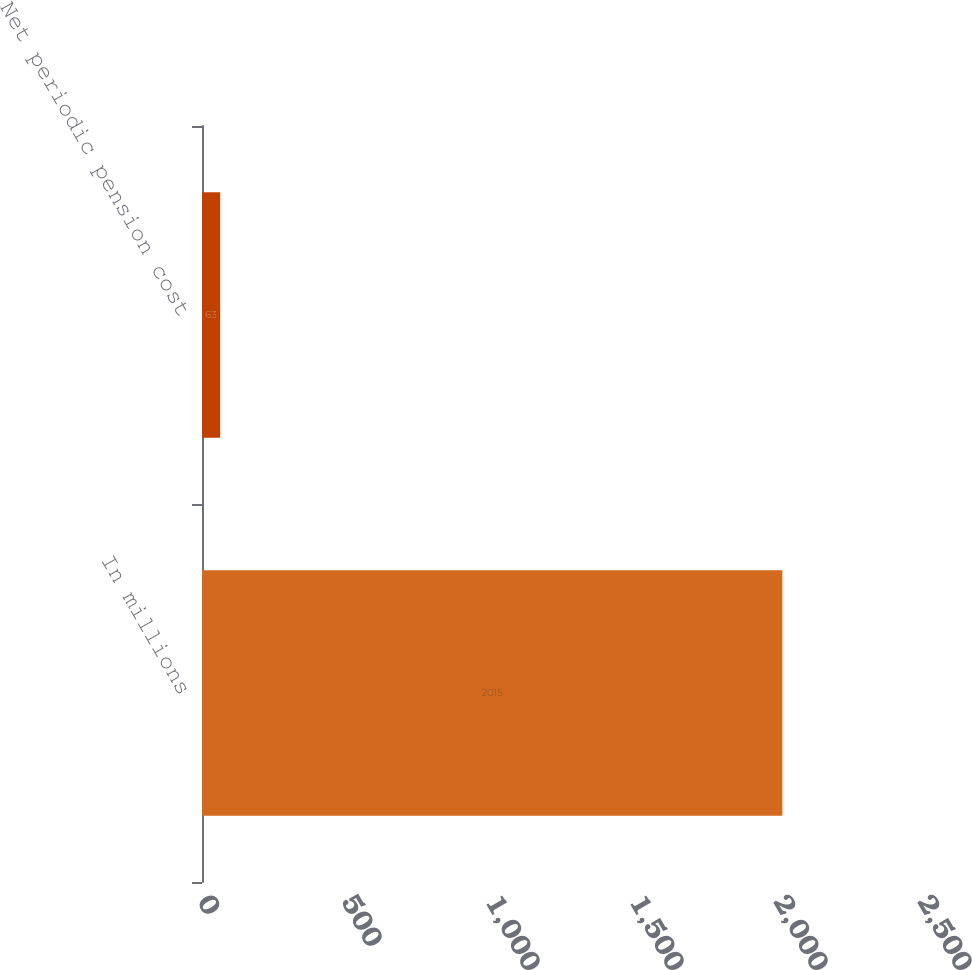Convert chart. <chart><loc_0><loc_0><loc_500><loc_500><bar_chart><fcel>In millions<fcel>Net periodic pension cost<nl><fcel>2015<fcel>63<nl></chart> 